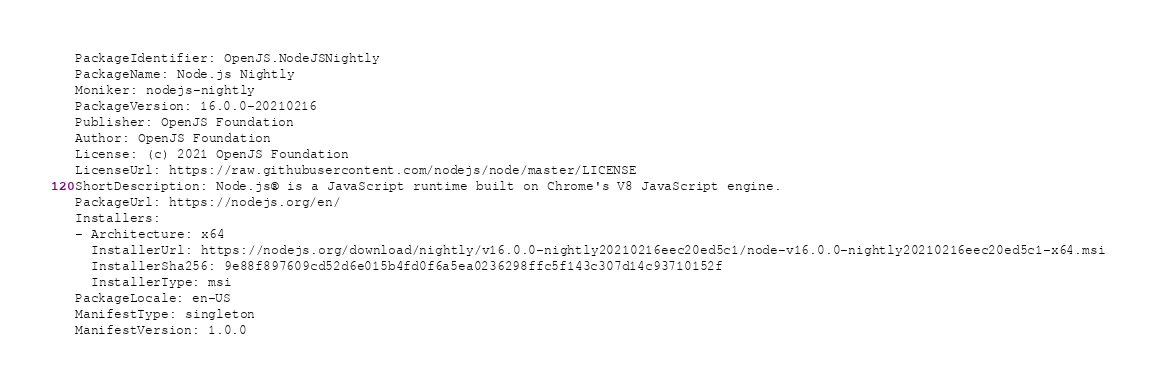<code> <loc_0><loc_0><loc_500><loc_500><_YAML_>PackageIdentifier: OpenJS.NodeJSNightly
PackageName: Node.js Nightly
Moniker: nodejs-nightly
PackageVersion: 16.0.0-20210216
Publisher: OpenJS Foundation
Author: OpenJS Foundation
License: (c) 2021 OpenJS Foundation
LicenseUrl: https://raw.githubusercontent.com/nodejs/node/master/LICENSE
ShortDescription: Node.js® is a JavaScript runtime built on Chrome's V8 JavaScript engine.
PackageUrl: https://nodejs.org/en/
Installers:
- Architecture: x64
  InstallerUrl: https://nodejs.org/download/nightly/v16.0.0-nightly20210216eec20ed5c1/node-v16.0.0-nightly20210216eec20ed5c1-x64.msi
  InstallerSha256: 9e88f897609cd52d6e015b4fd0f6a5ea0236298ffc5f143c307d14c93710152f
  InstallerType: msi
PackageLocale: en-US
ManifestType: singleton
ManifestVersion: 1.0.0
</code> 